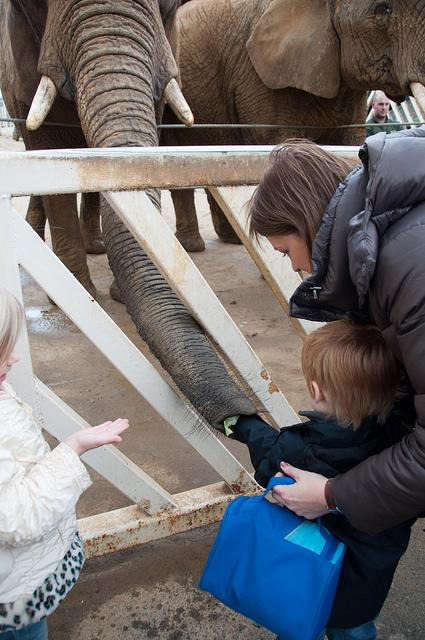Where are the elephants behind held? enclosure 